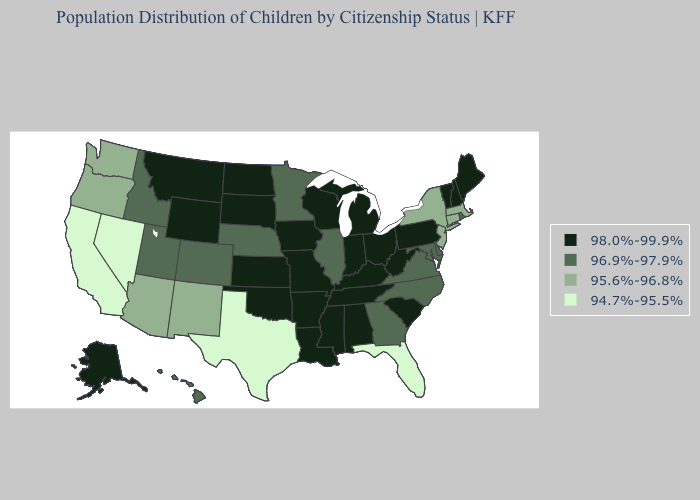Name the states that have a value in the range 98.0%-99.9%?
Be succinct. Alabama, Alaska, Arkansas, Indiana, Iowa, Kansas, Kentucky, Louisiana, Maine, Michigan, Mississippi, Missouri, Montana, New Hampshire, North Dakota, Ohio, Oklahoma, Pennsylvania, South Carolina, South Dakota, Tennessee, Vermont, West Virginia, Wisconsin, Wyoming. What is the highest value in states that border New York?
Answer briefly. 98.0%-99.9%. Does the map have missing data?
Keep it brief. No. Which states have the lowest value in the USA?
Concise answer only. California, Florida, Nevada, Texas. Name the states that have a value in the range 98.0%-99.9%?
Quick response, please. Alabama, Alaska, Arkansas, Indiana, Iowa, Kansas, Kentucky, Louisiana, Maine, Michigan, Mississippi, Missouri, Montana, New Hampshire, North Dakota, Ohio, Oklahoma, Pennsylvania, South Carolina, South Dakota, Tennessee, Vermont, West Virginia, Wisconsin, Wyoming. Which states hav the highest value in the Northeast?
Write a very short answer. Maine, New Hampshire, Pennsylvania, Vermont. What is the lowest value in the USA?
Quick response, please. 94.7%-95.5%. Does the first symbol in the legend represent the smallest category?
Answer briefly. No. What is the lowest value in the USA?
Be succinct. 94.7%-95.5%. What is the value of Connecticut?
Be succinct. 95.6%-96.8%. Name the states that have a value in the range 94.7%-95.5%?
Quick response, please. California, Florida, Nevada, Texas. Among the states that border Louisiana , which have the highest value?
Be succinct. Arkansas, Mississippi. What is the value of Arkansas?
Quick response, please. 98.0%-99.9%. Does the first symbol in the legend represent the smallest category?
Concise answer only. No. Name the states that have a value in the range 96.9%-97.9%?
Give a very brief answer. Colorado, Delaware, Georgia, Hawaii, Idaho, Illinois, Maryland, Minnesota, Nebraska, North Carolina, Rhode Island, Utah, Virginia. 